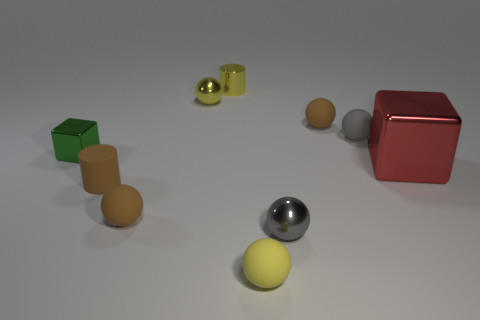There is a metal sphere that is to the left of the tiny rubber thing in front of the small gray metal ball; what color is it?
Keep it short and to the point. Yellow. Are the large red block and the gray ball that is in front of the gray rubber thing made of the same material?
Offer a very short reply. Yes. There is a small gray thing that is behind the small brown matte cylinder; what is its material?
Offer a very short reply. Rubber. Are there the same number of brown rubber spheres that are right of the red block and large gray matte blocks?
Your answer should be compact. Yes. Is there anything else that is the same size as the green cube?
Ensure brevity in your answer.  Yes. What is the material of the small gray sphere in front of the block that is in front of the green block?
Make the answer very short. Metal. There is a matte object that is left of the small gray matte ball and behind the small green object; what shape is it?
Keep it short and to the point. Sphere. There is a green thing that is the same shape as the big red object; what is its size?
Your response must be concise. Small. Are there fewer small spheres right of the small gray matte sphere than small blocks?
Ensure brevity in your answer.  Yes. How big is the brown object that is right of the tiny yellow cylinder?
Give a very brief answer. Small. 